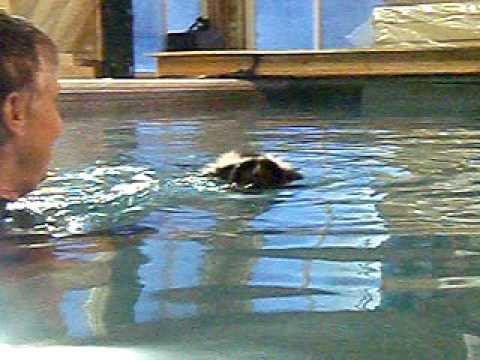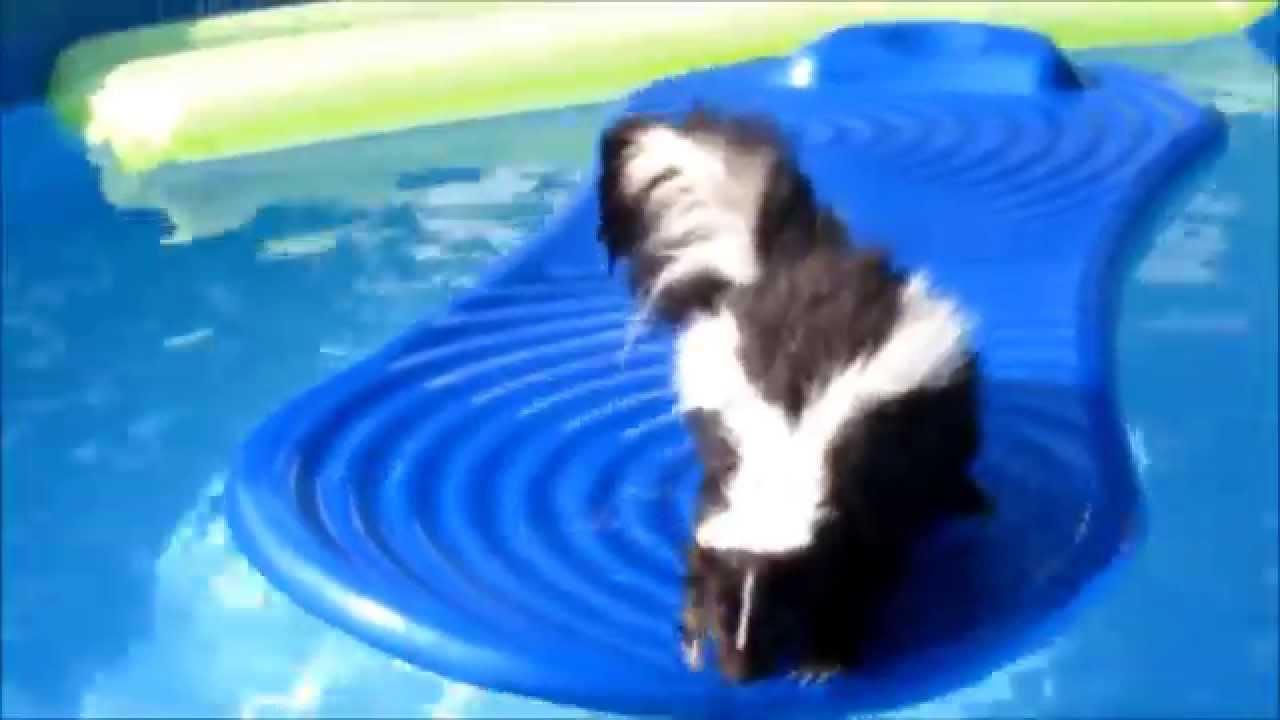The first image is the image on the left, the second image is the image on the right. Examine the images to the left and right. Is the description "In at least one image there is a skunk sitting on a blue raft in a pool." accurate? Answer yes or no. Yes. The first image is the image on the left, the second image is the image on the right. Examine the images to the left and right. Is the description "The skunk in one of the images is sitting on a float in a pool, while in the other image it is swimming freely in the water." accurate? Answer yes or no. Yes. 